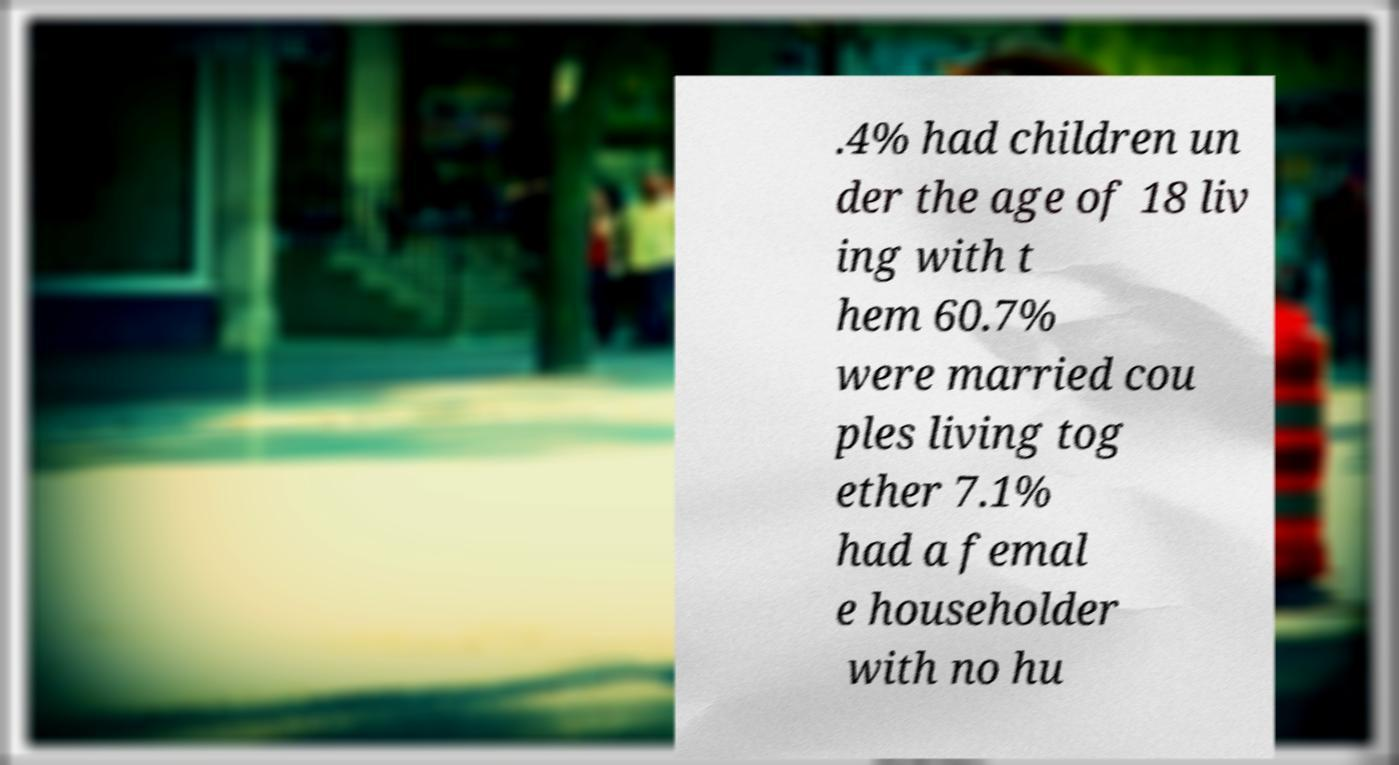For documentation purposes, I need the text within this image transcribed. Could you provide that? .4% had children un der the age of 18 liv ing with t hem 60.7% were married cou ples living tog ether 7.1% had a femal e householder with no hu 